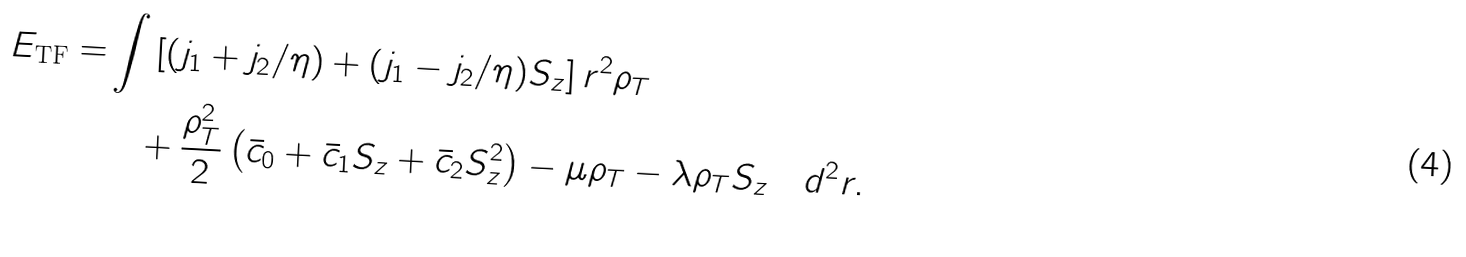<formula> <loc_0><loc_0><loc_500><loc_500>E _ { \text {TF} } = & \int \left [ ( j _ { 1 } + j _ { 2 } / \eta ) + ( j _ { 1 } - j _ { 2 } / \eta ) S _ { z } \right ] r ^ { 2 } \rho _ { T } \\ & \quad + \frac { \rho _ { T } ^ { 2 } } { 2 } \left ( \bar { c } _ { 0 } + \bar { c } _ { 1 } S _ { z } + \bar { c } _ { 2 } S _ { z } ^ { 2 } \right ) - \mu \rho _ { T } - \lambda \rho _ { T } S _ { z } \quad d ^ { 2 } r .</formula> 